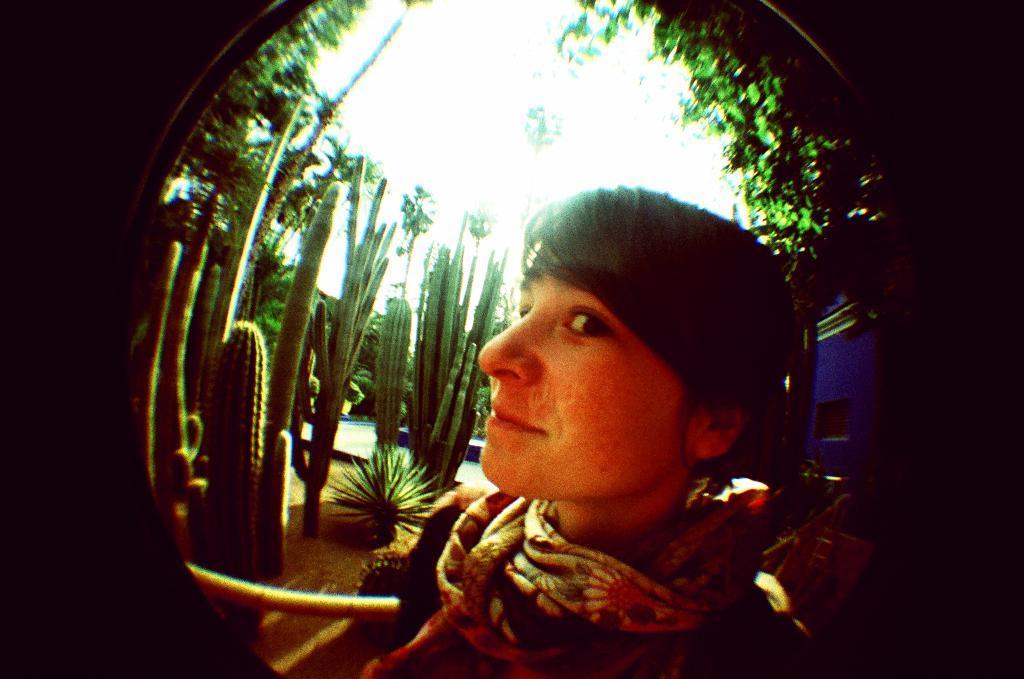How would you summarize this image in a sentence or two? This picture seems to be an edited image. In the foreground we can see a person wearing a scarf and seems to be standing. In the background we can see the sky, trees, cactus, plants and some other objects. 